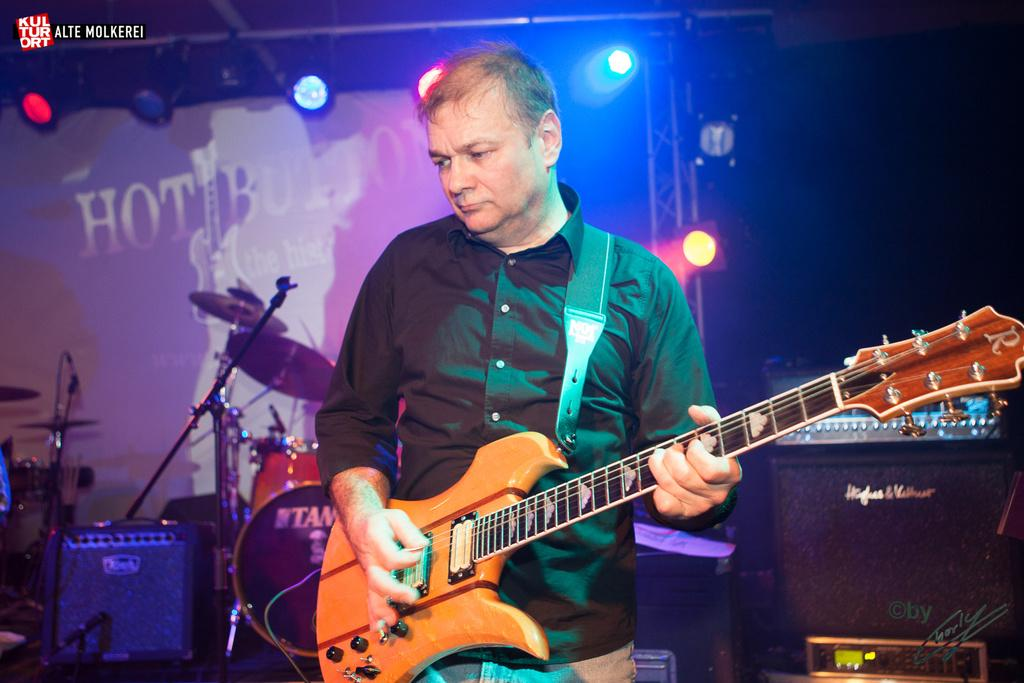Who is the person in the image? There is a man in the image. What is the man holding in the image? The man is holding a guitar. What can be seen in the background of the image? There are musical instruments and equipment visible in the background of the image. What else can be seen in the background of the image? Lights are present in the background of the image. What book is the man reading in the image? There is no book present in the image, and the man is not reading. 